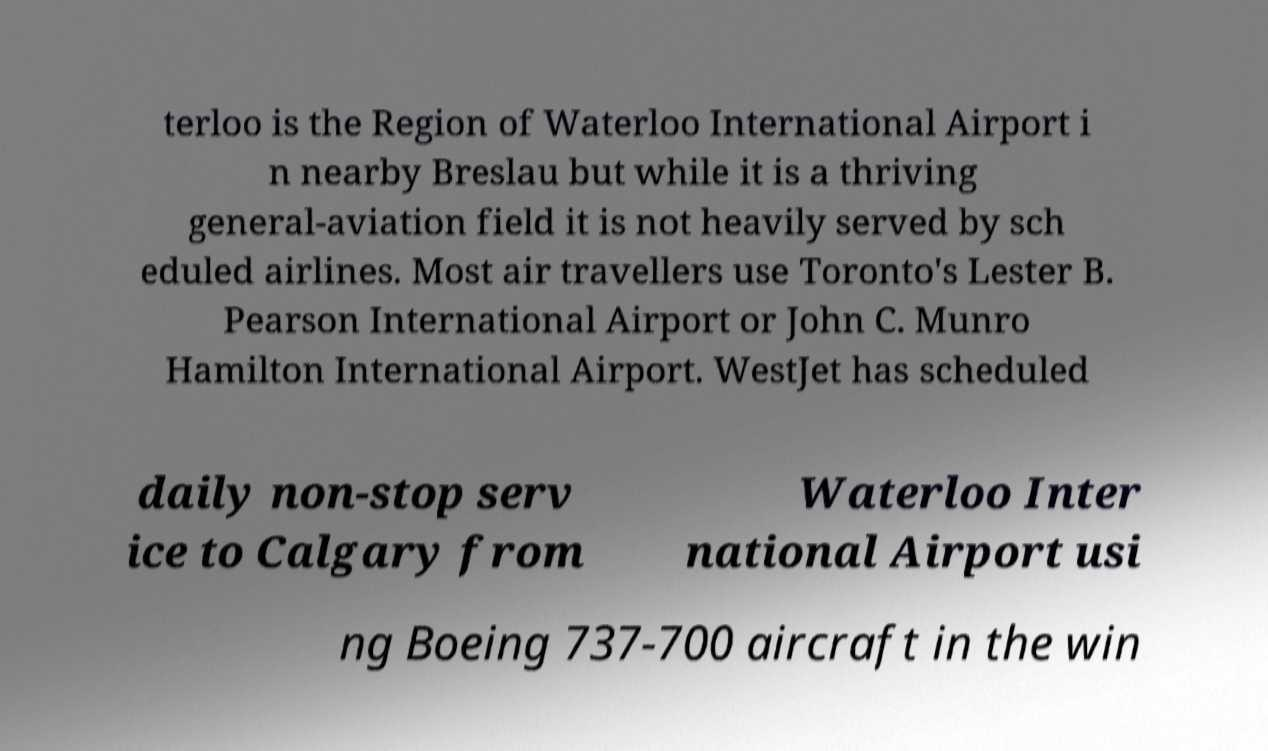Please read and relay the text visible in this image. What does it say? terloo is the Region of Waterloo International Airport i n nearby Breslau but while it is a thriving general-aviation field it is not heavily served by sch eduled airlines. Most air travellers use Toronto's Lester B. Pearson International Airport or John C. Munro Hamilton International Airport. WestJet has scheduled daily non-stop serv ice to Calgary from Waterloo Inter national Airport usi ng Boeing 737-700 aircraft in the win 